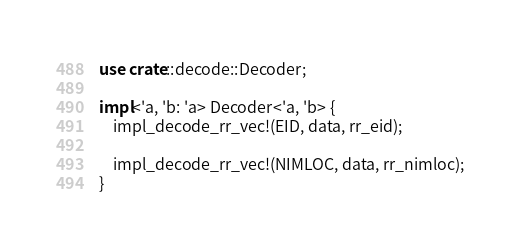Convert code to text. <code><loc_0><loc_0><loc_500><loc_500><_Rust_>use crate::decode::Decoder;

impl<'a, 'b: 'a> Decoder<'a, 'b> {
    impl_decode_rr_vec!(EID, data, rr_eid);

    impl_decode_rr_vec!(NIMLOC, data, rr_nimloc);
}
</code> 